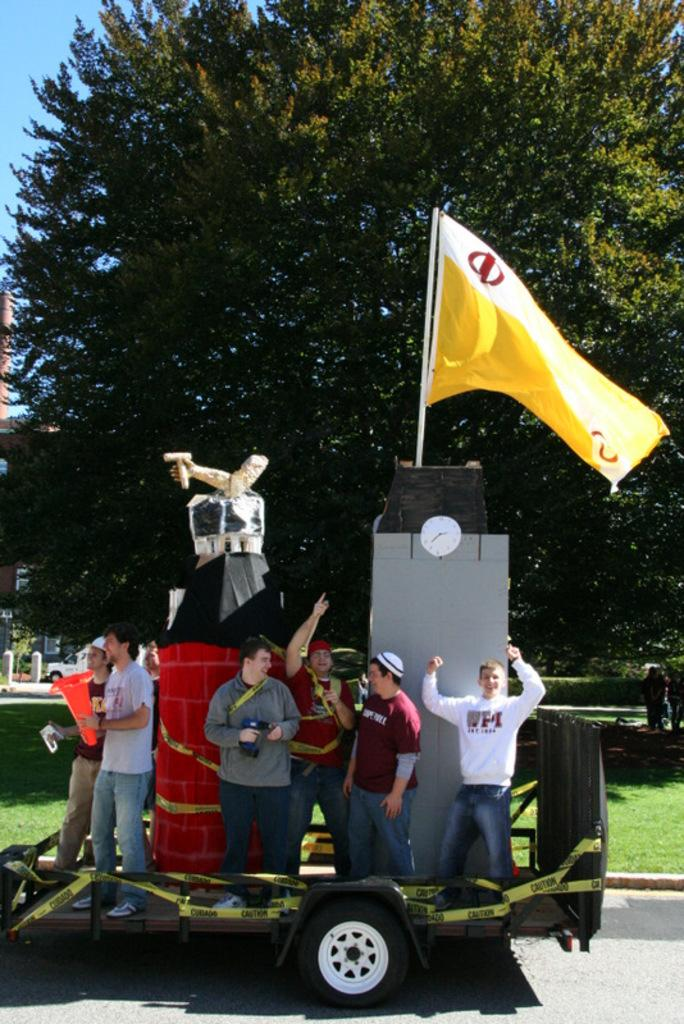What is the main subject of the image? There is a vehicle in the image. What are the people doing in the image? There are people standing on the vehicle. What can be seen besides the vehicle and people? There is a flag and a green tree in the image. What is visible in the top right corner of the image? The sky is blue and visible at the top right side of the image. What time is displayed on the clock in the image? There is no clock present in the image. Can you describe the shock experienced by the people on the vehicle? There is no indication of shock or any other emotional state in the image; the people are simply standing on the vehicle. 